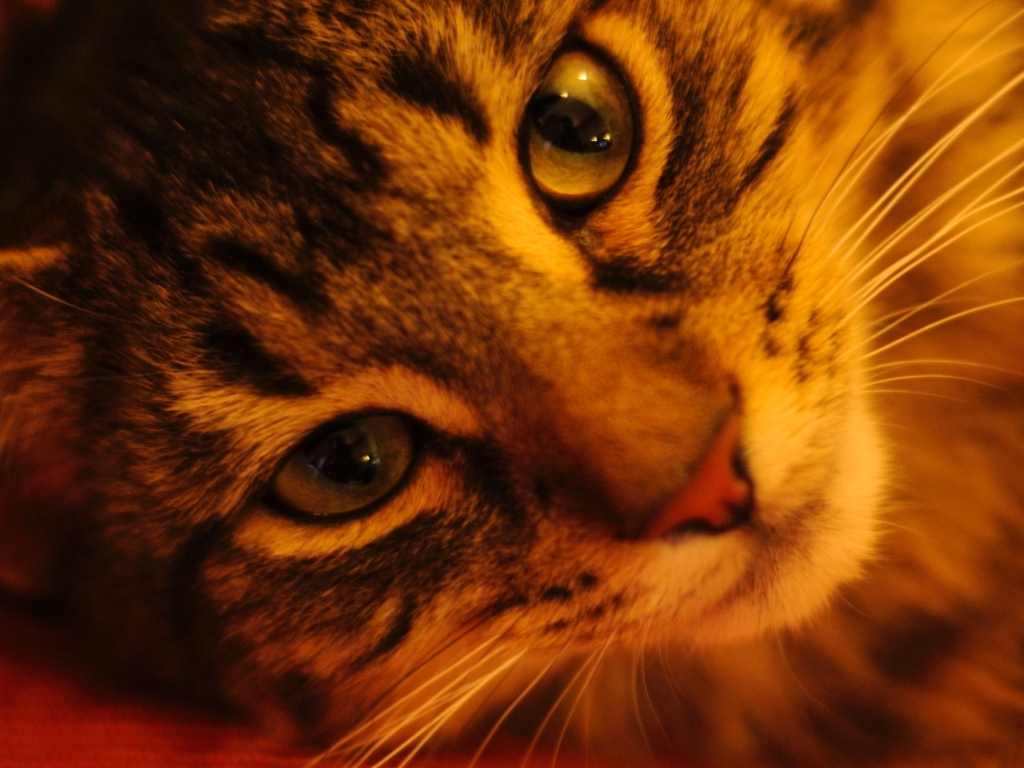Could this image be used for a specific purpose? Certainly, this image could be perfect for several uses. It has the potential for a pet adoption flyer, an illustration for a story or article about pets, or even to set a calming mood as a decorative picture in a veterinarian’s office space. 